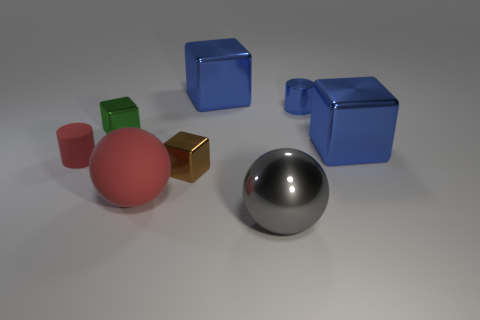Subtract all small brown blocks. How many blocks are left? 3 Add 2 green shiny objects. How many objects exist? 10 Subtract 2 cubes. How many cubes are left? 2 Subtract all blue cylinders. How many cylinders are left? 1 Subtract all cylinders. How many objects are left? 6 Subtract 1 blue cylinders. How many objects are left? 7 Subtract all brown balls. Subtract all cyan cylinders. How many balls are left? 2 Subtract all red balls. How many brown cubes are left? 1 Subtract all small yellow cubes. Subtract all big rubber things. How many objects are left? 7 Add 6 red matte cylinders. How many red matte cylinders are left? 7 